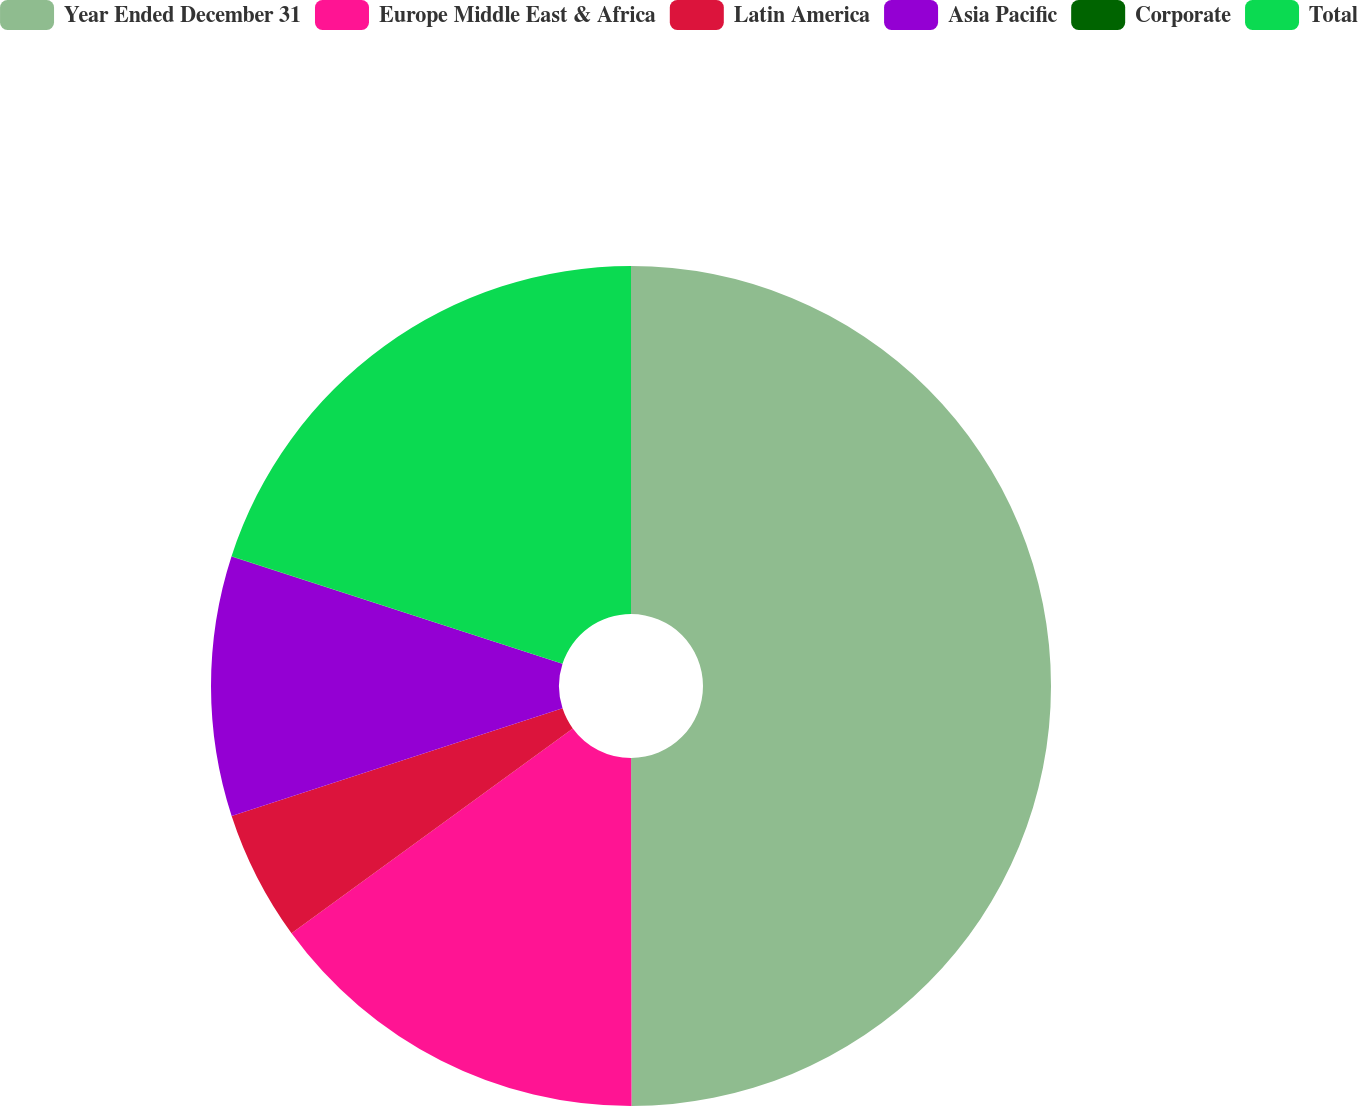Convert chart. <chart><loc_0><loc_0><loc_500><loc_500><pie_chart><fcel>Year Ended December 31<fcel>Europe Middle East & Africa<fcel>Latin America<fcel>Asia Pacific<fcel>Corporate<fcel>Total<nl><fcel>49.98%<fcel>15.0%<fcel>5.01%<fcel>10.0%<fcel>0.01%<fcel>20.0%<nl></chart> 